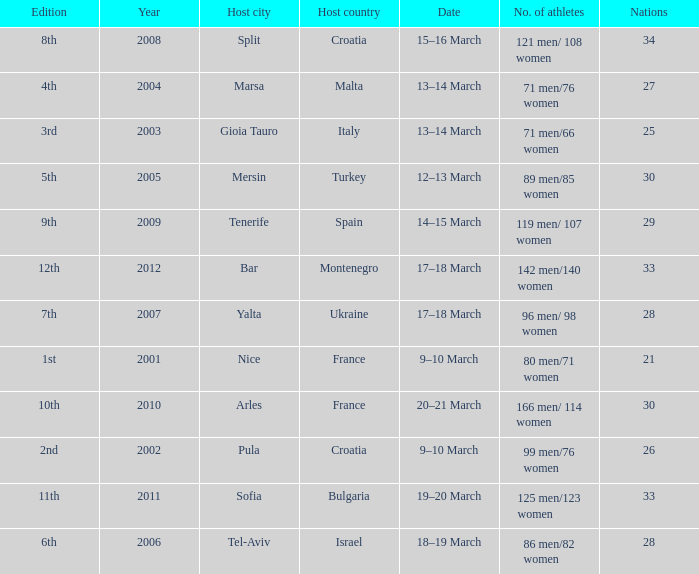What was the number of athletes in the host city of Nice? 80 men/71 women. 